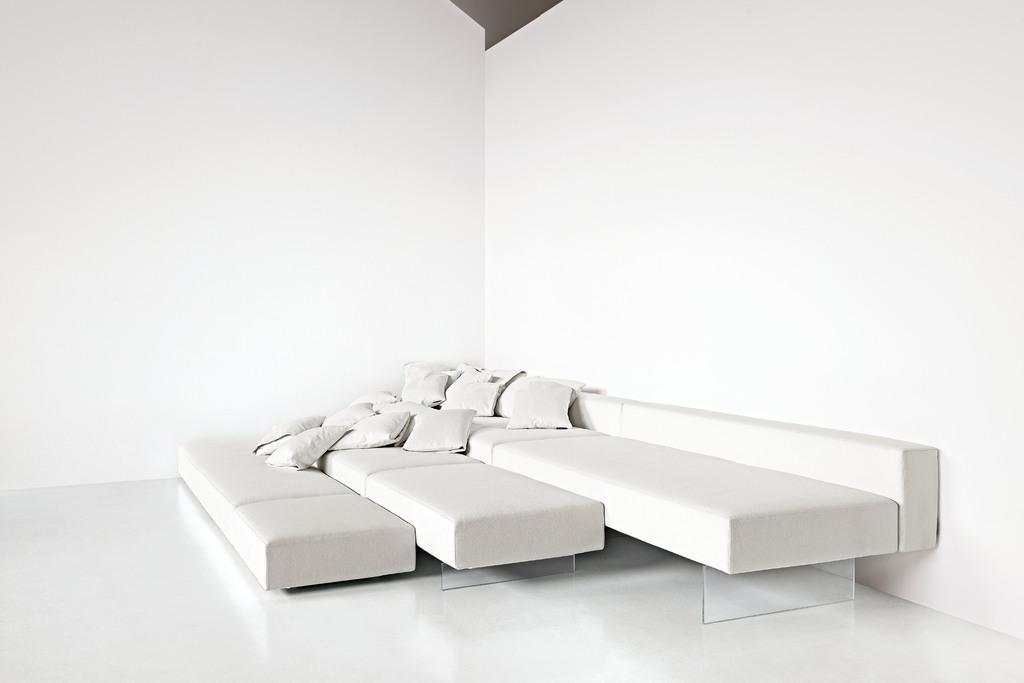Could you give a brief overview of what you see in this image? In this image I can see a sofa and few cushions on it. 